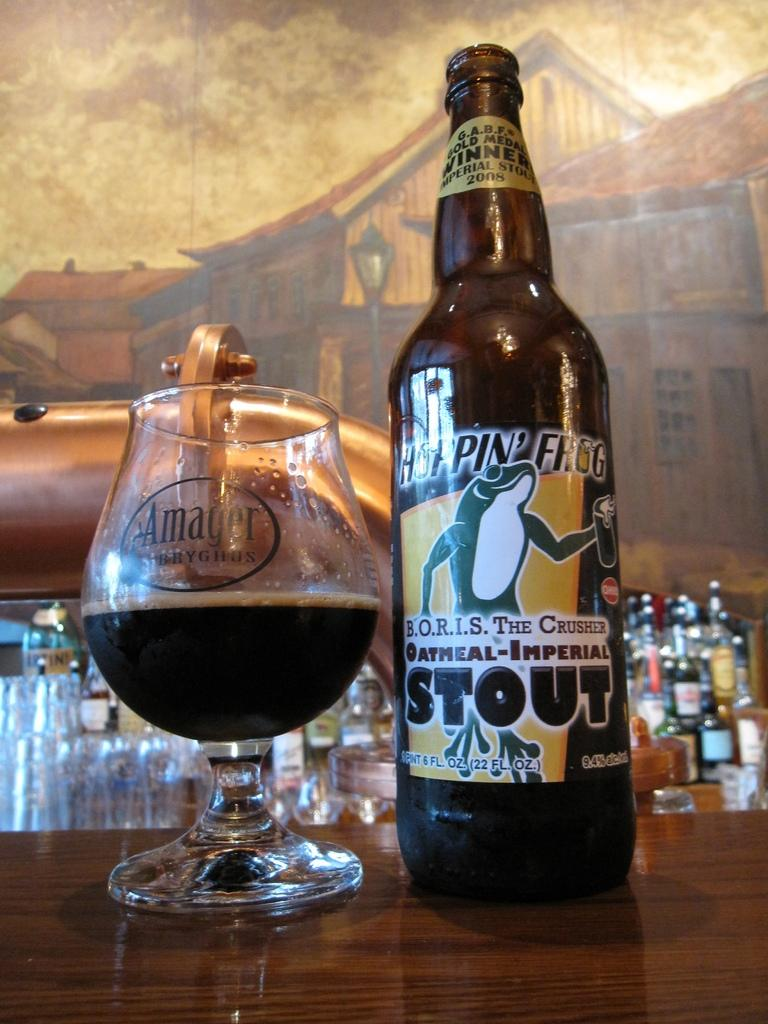<image>
Summarize the visual content of the image. A bottle of oatmeal-imperial stout is next to a glass. 